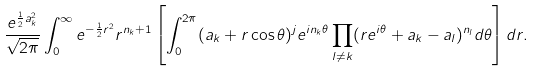<formula> <loc_0><loc_0><loc_500><loc_500>\frac { e ^ { \frac { 1 } { 2 } a _ { k } ^ { 2 } } } { \sqrt { 2 \pi } } \int _ { 0 } ^ { \infty } e ^ { - \frac { 1 } { 2 } r ^ { 2 } } r ^ { n _ { k } + 1 } \left [ \int _ { 0 } ^ { 2 \pi } ( a _ { k } + r \cos \theta ) ^ { j } e ^ { i n _ { k } \theta } \prod _ { l \neq k } ( r e ^ { i \theta } + a _ { k } - a _ { l } ) ^ { n _ { l } } d \theta \right ] d r .</formula> 